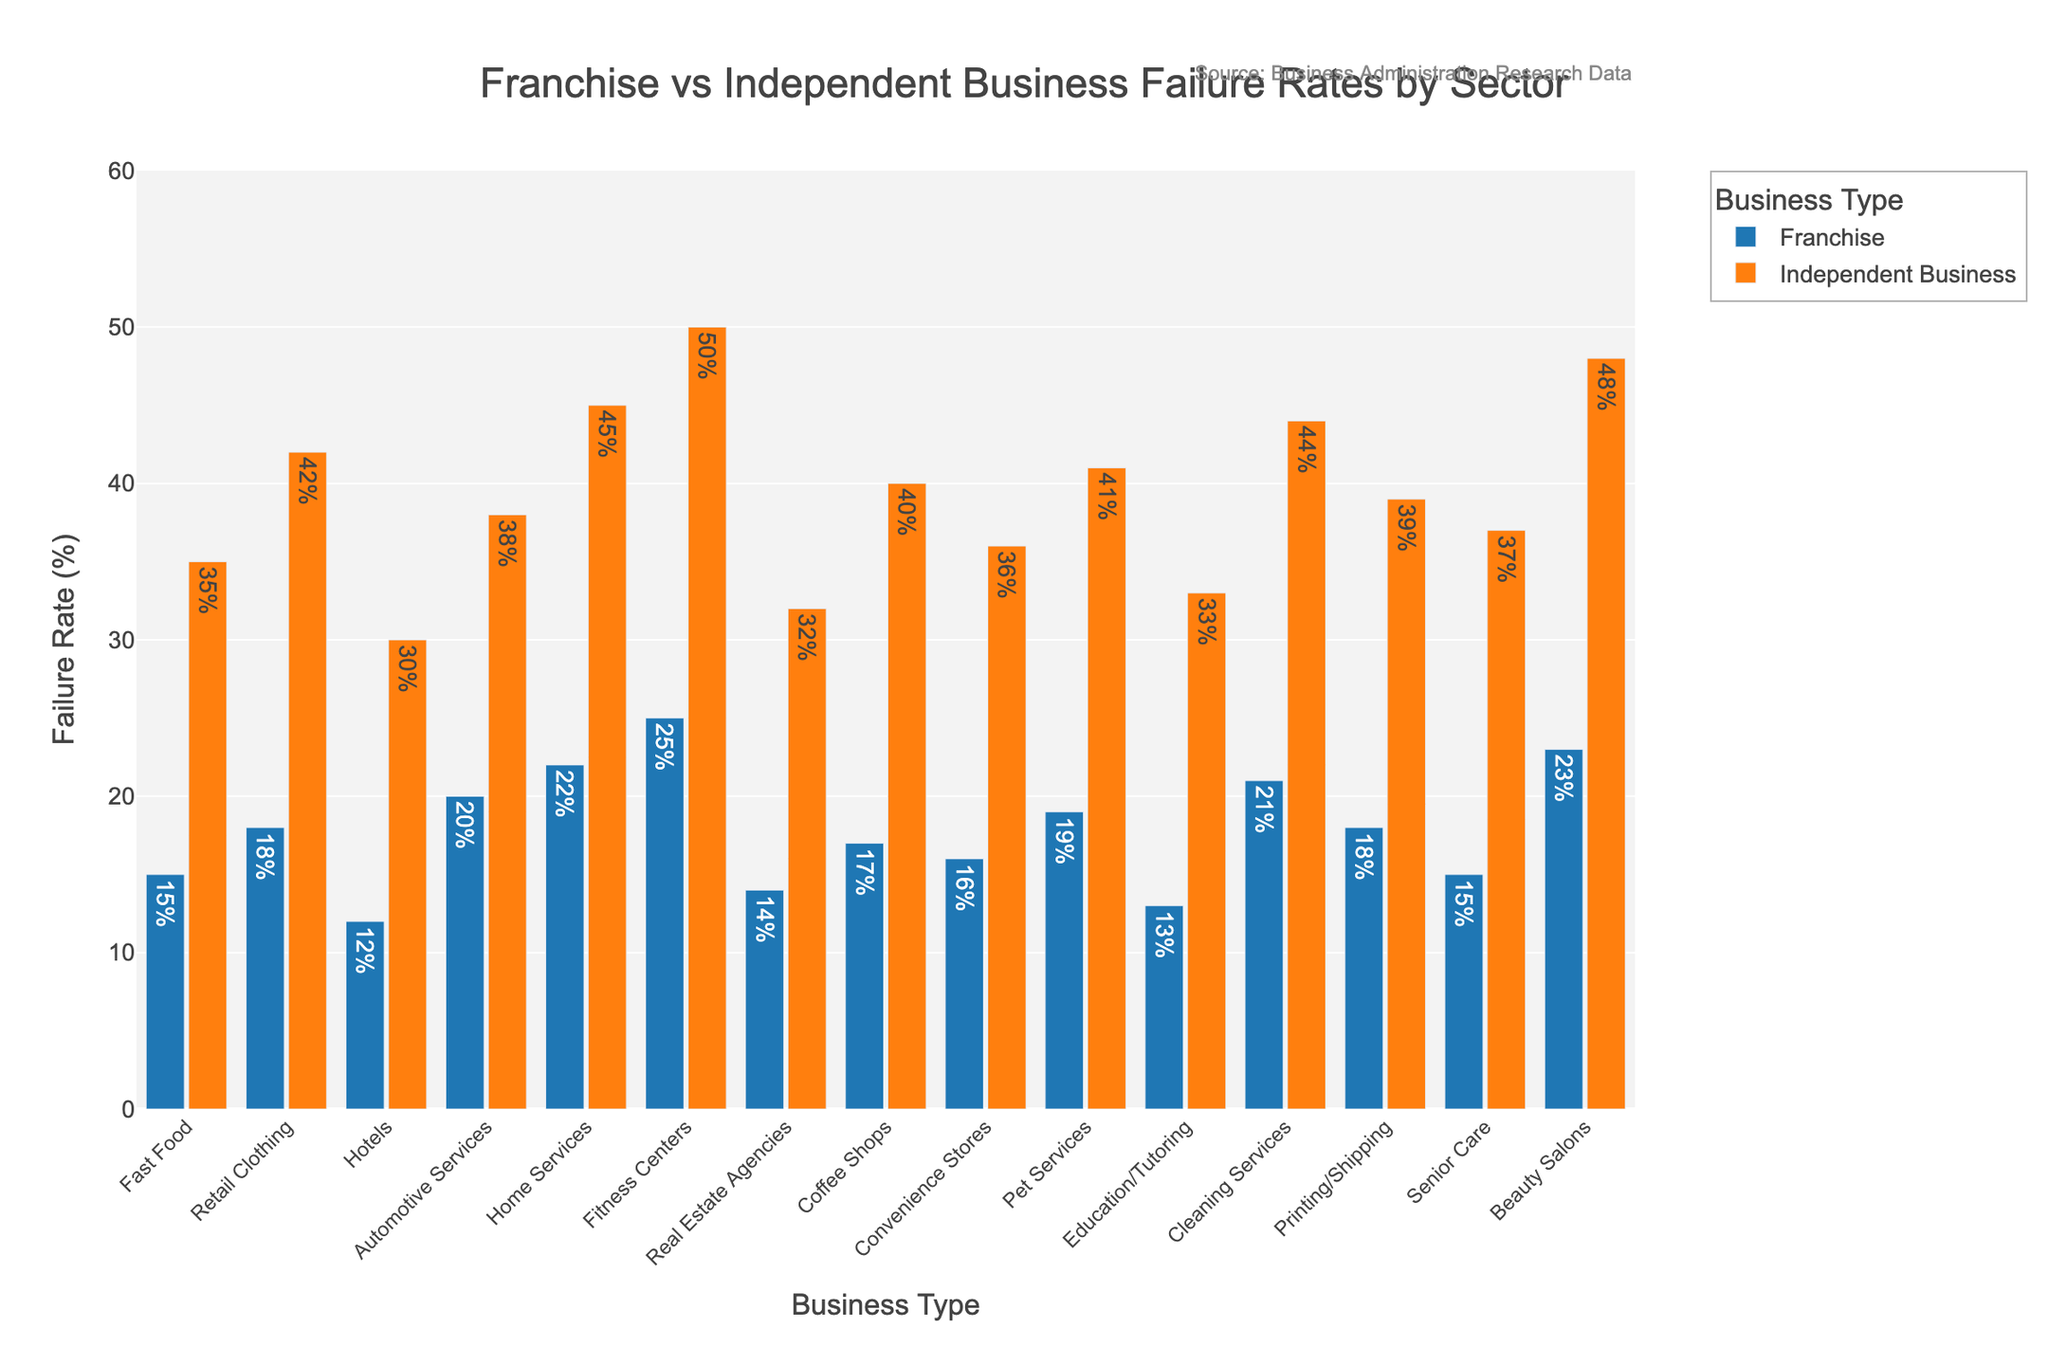What's the difference in failure rates between franchises and independent businesses in the Fast Food sector? Find the failure rates for both types and subtract them: Independent Business Failure Rate (35%) - Franchise Failure Rate (15%) = 20%
Answer: 20% Which sector has the highest franchise failure rate? Look for the tallest blue bar in the chart (Franchise bars). The Fitness Centers sector has the highest franchise failure rate at 25%
Answer: Fitness Centers In how many sectors are franchise failure rates lower than independent business failure rates? Count the sectors where the blue bar (Franchise) is shorter than the orange bar (Independent Business). All 15 sectors show this trend.
Answer: 15 What is the average failure rate of franchises across all sectors? Sum the franchise failure rates and divide by the number of sectors: (15 + 18 + 12 + 20 + 22 + 25 + 14 + 17 + 16 + 19 + 13 + 21 + 18 + 15 + 23) / 15 = 277 / 15 ≈ 18.47%
Answer: 18.47 Which sector shows the smallest difference in failure rates between franchises and independent businesses? Calculate the difference in failure rates for each sector and find the smallest: Hotels sector with a difference of 18% (30% - 12%)
Answer: Hotels What is the combined failure rate percentage for franchises in the Fast Food and Retail Clothing sectors? Add the failure rates for these sectors: 15% (Fast Food) + 18% (Retail Clothing) = 33%
Answer: 33% Does any sector have the same failure rate difference between franchises and independent businesses? Calculate the difference for each sector and see if any of them match: Fast Food and Printing/Shipping sectors both have a difference of 20%
Answer: Yes, Fast Food and Printing/Shipping Which sector shows a franchise failure rate lower than 20% but an independent business failure rate higher than 40%? Find sectors where the blue bar is below 20% and the orange bar is above 40%. Retail Clothing (18%, 42%) and Home Services (22%, 45%)
Answer: Retail Clothing and Home Services 